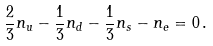Convert formula to latex. <formula><loc_0><loc_0><loc_500><loc_500>\frac { 2 } { 3 } n _ { u } - \frac { 1 } { 3 } n _ { d } - \frac { 1 } { 3 } n _ { s } - n _ { e } = 0 \, .</formula> 